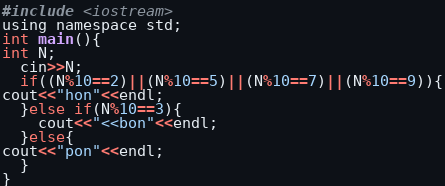<code> <loc_0><loc_0><loc_500><loc_500><_C_>#include <iostream>
using namespace std;
int main(){
int N;
  cin>>N;
  if((N%10==2)||(N%10==5)||(N%10==7)||(N%10==9)){
cout<<"hon"<<endl;
  }else if(N%10==3){
    cout<<"<<bon"<<endl;
  }else{
cout<<"pon"<<endl;
  }
}</code> 